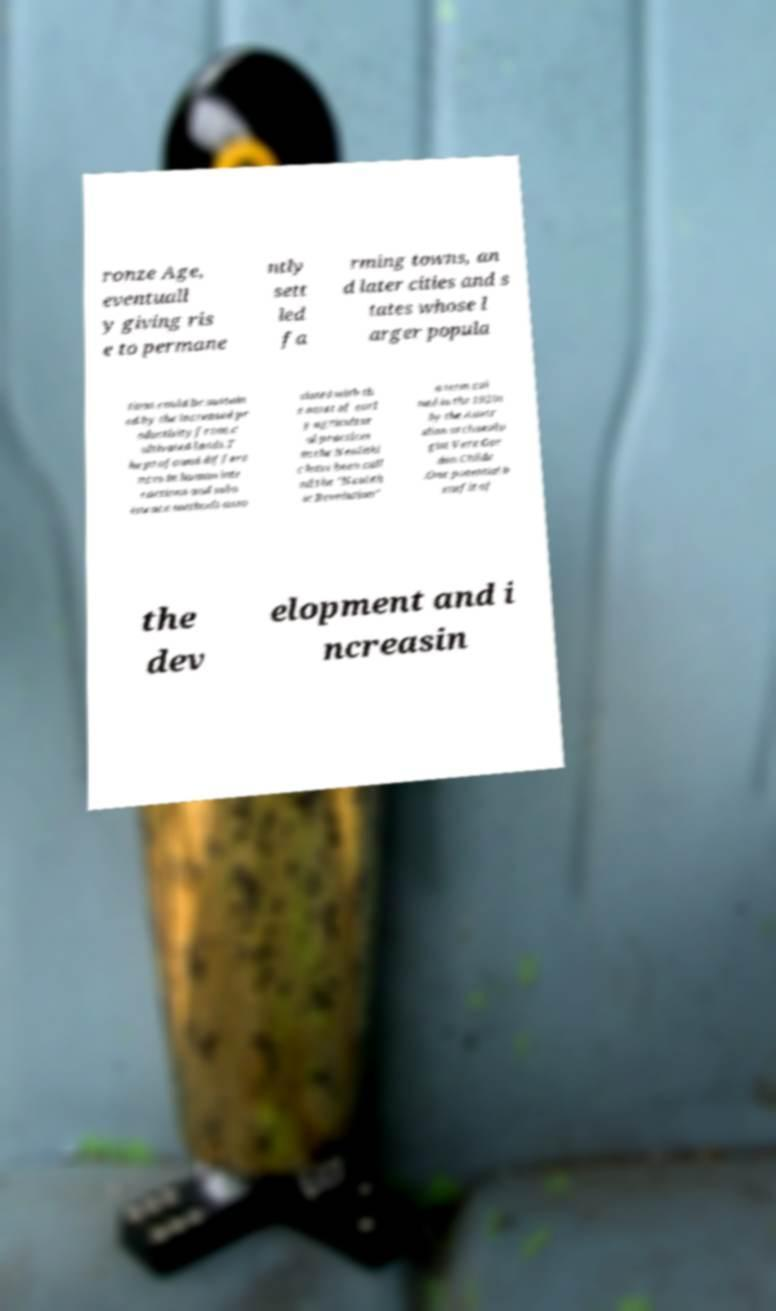Can you accurately transcribe the text from the provided image for me? ronze Age, eventuall y giving ris e to permane ntly sett led fa rming towns, an d later cities and s tates whose l arger popula tions could be sustain ed by the increased pr oductivity from c ultivated lands.T he profound differe nces in human inte ractions and subs istence methods asso ciated with th e onset of earl y agricultur al practices in the Neolithi c have been call ed the "Neolith ic Revolution" a term coi ned in the 1920s by the Austr alian archaeolo gist Vere Gor don Childe .One potential b enefit of the dev elopment and i ncreasin 